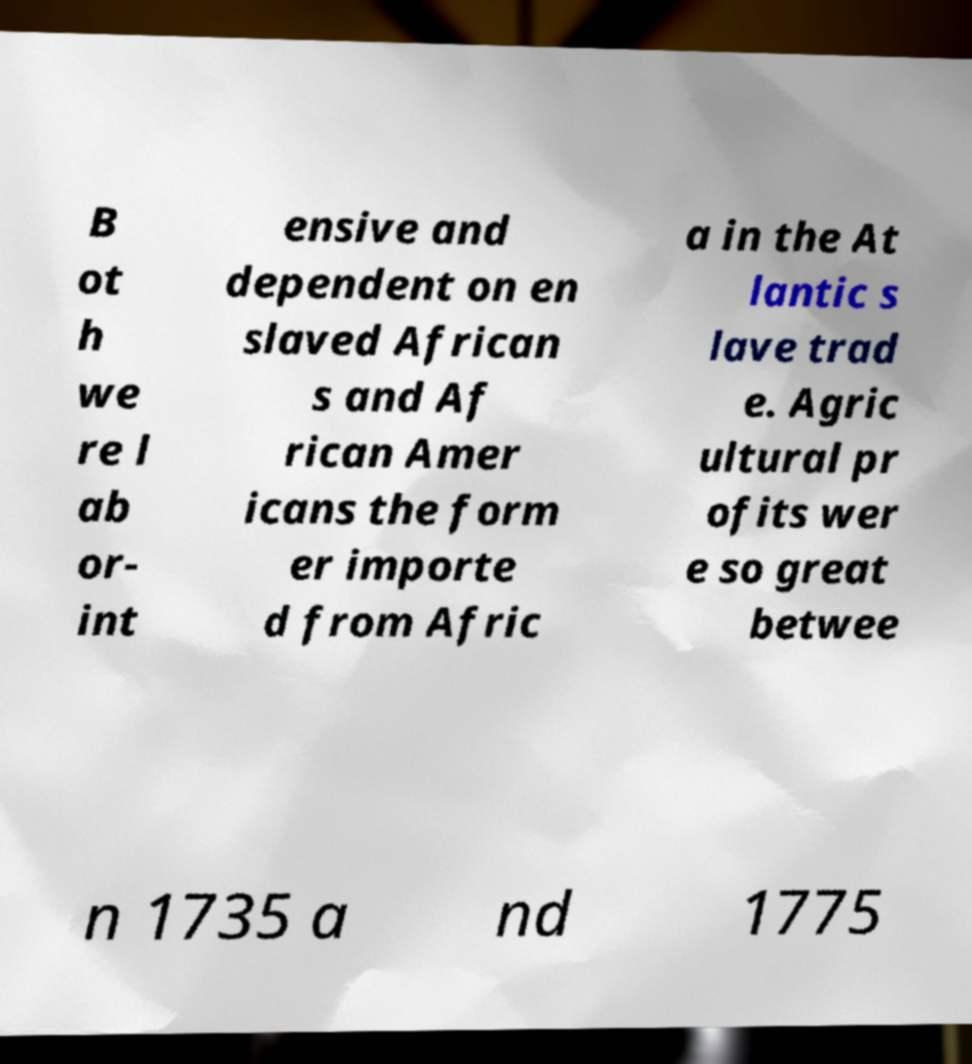Can you accurately transcribe the text from the provided image for me? B ot h we re l ab or- int ensive and dependent on en slaved African s and Af rican Amer icans the form er importe d from Afric a in the At lantic s lave trad e. Agric ultural pr ofits wer e so great betwee n 1735 a nd 1775 